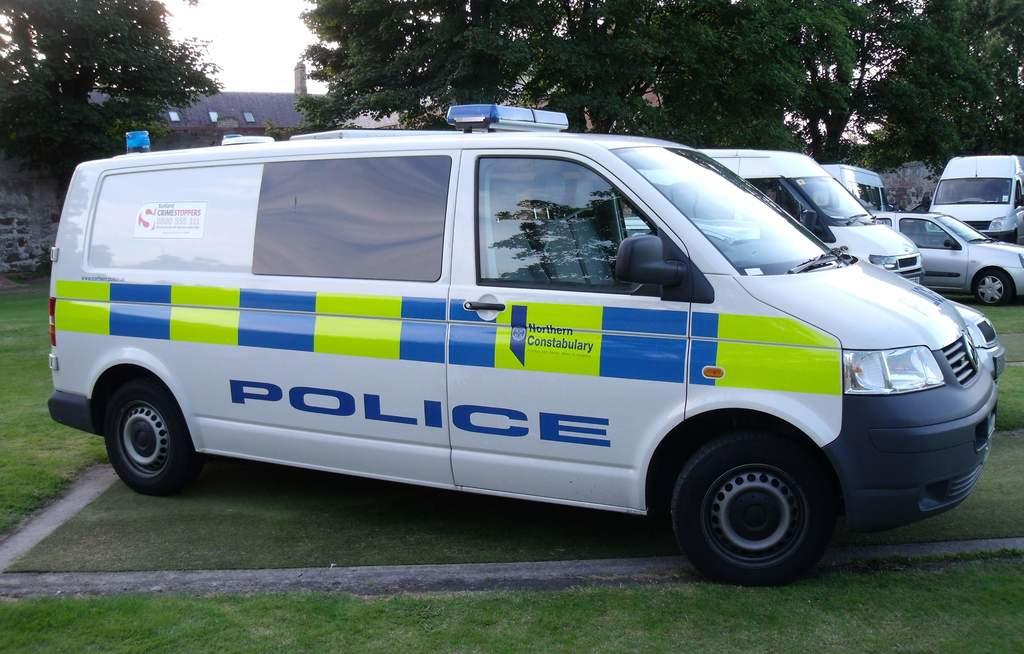What kind of van is that?
Ensure brevity in your answer.  Police. What area is the van from?
Offer a terse response. Northern constabulary. 